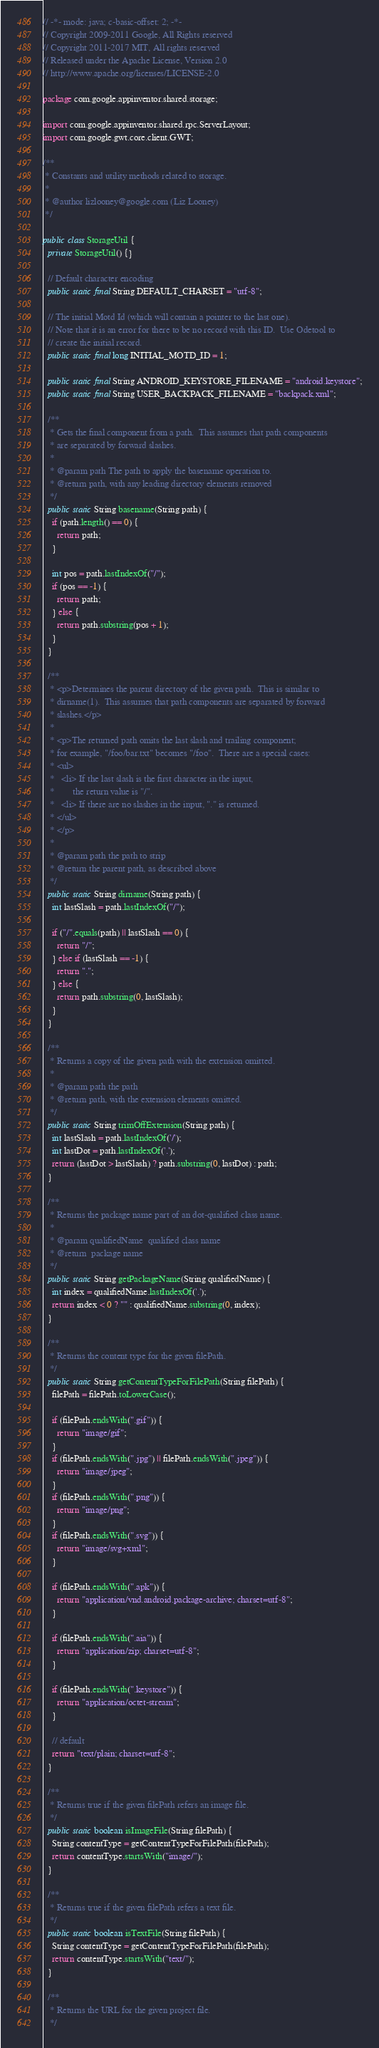Convert code to text. <code><loc_0><loc_0><loc_500><loc_500><_Java_>// -*- mode: java; c-basic-offset: 2; -*-
// Copyright 2009-2011 Google, All Rights reserved
// Copyright 2011-2017 MIT, All rights reserved
// Released under the Apache License, Version 2.0
// http://www.apache.org/licenses/LICENSE-2.0

package com.google.appinventor.shared.storage;

import com.google.appinventor.shared.rpc.ServerLayout;
import com.google.gwt.core.client.GWT;

/**
 * Constants and utility methods related to storage.
 *
 * @author lizlooney@google.com (Liz Looney)
 */

public class StorageUtil {
  private StorageUtil() {}

  // Default character encoding
  public static final String DEFAULT_CHARSET = "utf-8";

  // The initial Motd Id (which will contain a pointer to the last one).
  // Note that it is an error for there to be no record with this ID.  Use Odetool to
  // create the initial record.
  public static final long INITIAL_MOTD_ID = 1;

  public static final String ANDROID_KEYSTORE_FILENAME = "android.keystore";
  public static final String USER_BACKPACK_FILENAME = "backpack.xml";

  /**
   * Gets the final component from a path.  This assumes that path components
   * are separated by forward slashes.
   *
   * @param path The path to apply the basename operation to.
   * @return path, with any leading directory elements removed
   */
  public static String basename(String path) {
    if (path.length() == 0) {
      return path;
    }

    int pos = path.lastIndexOf("/");
    if (pos == -1) {
      return path;
    } else {
      return path.substring(pos + 1);
    }
  }

  /**
   * <p>Determines the parent directory of the given path.  This is similar to
   * dirname(1).  This assumes that path components are separated by forward
   * slashes.</p>
   *
   * <p>The returned path omits the last slash and trailing component;
   * for example, "/foo/bar.txt" becomes "/foo".  There are a special cases:
   * <ul>
   *   <li> If the last slash is the first character in the input,
   *        the return value is "/".
   *   <li> If there are no slashes in the input, "." is returned.
   * </ul>
   * </p>
   *
   * @param path the path to strip
   * @return the parent path, as described above
   */
  public static String dirname(String path) {
    int lastSlash = path.lastIndexOf("/");

    if ("/".equals(path) || lastSlash == 0) {
      return "/";
    } else if (lastSlash == -1) {
      return ".";
    } else {
      return path.substring(0, lastSlash);
    }
  }

  /**
   * Returns a copy of the given path with the extension omitted.
   *
   * @param path the path
   * @return path, with the extension elements omitted.
   */
  public static String trimOffExtension(String path) {
    int lastSlash = path.lastIndexOf('/');
    int lastDot = path.lastIndexOf('.');
    return (lastDot > lastSlash) ? path.substring(0, lastDot) : path;
  }

  /**
   * Returns the package name part of an dot-qualified class name.
   *
   * @param qualifiedName  qualified class name
   * @return  package name
   */
  public static String getPackageName(String qualifiedName) {
    int index = qualifiedName.lastIndexOf('.');
    return index < 0 ? "" : qualifiedName.substring(0, index);
  }

  /**
   * Returns the content type for the given filePath.
   */
  public static String getContentTypeForFilePath(String filePath) {
    filePath = filePath.toLowerCase();

    if (filePath.endsWith(".gif")) {
      return "image/gif";
    }
    if (filePath.endsWith(".jpg") || filePath.endsWith(".jpeg")) {
      return "image/jpeg";
    }
    if (filePath.endsWith(".png")) {
      return "image/png";
    }
    if (filePath.endsWith(".svg")) {
      return "image/svg+xml";
    }

    if (filePath.endsWith(".apk")) {
      return "application/vnd.android.package-archive; charset=utf-8";
    }

    if (filePath.endsWith(".aia")) {
      return "application/zip; charset=utf-8";
    }

    if (filePath.endsWith(".keystore")) {
      return "application/octet-stream";
    }

    // default
    return "text/plain; charset=utf-8";
  }

  /**
   * Returns true if the given filePath refers an image file.
   */
  public static boolean isImageFile(String filePath) {
    String contentType = getContentTypeForFilePath(filePath);
    return contentType.startsWith("image/");
  }

  /**
   * Returns true if the given filePath refers a text file.
   */
  public static boolean isTextFile(String filePath) {
    String contentType = getContentTypeForFilePath(filePath);
    return contentType.startsWith("text/");
  }

  /**
   * Returns the URL for the given project file.
   */</code> 